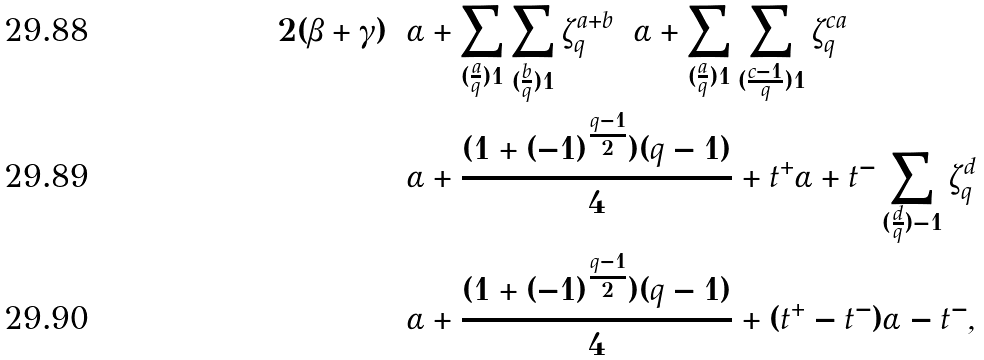<formula> <loc_0><loc_0><loc_500><loc_500>2 ( \beta + \gamma ) & = \alpha + \sum _ { ( \frac { a } { q } ) = 1 } \sum _ { ( \frac { b } { q } ) = 1 } \zeta _ { q } ^ { a + b } = \alpha + \sum _ { ( \frac { a } { q } ) = 1 } \sum _ { ( \frac { c - 1 } q ) = 1 } \zeta _ { q } ^ { c a } \\ & = \alpha + \frac { ( 1 + ( - 1 ) ^ { \frac { q - 1 } 2 } ) ( q - 1 ) } 4 + t ^ { + } \alpha + t ^ { - } \sum _ { ( \frac { d } { q } ) = - 1 } \zeta _ { q } ^ { d } \\ & = \alpha + \frac { ( 1 + ( - 1 ) ^ { \frac { q - 1 } 2 } ) ( q - 1 ) } 4 + ( t ^ { + } - t ^ { - } ) \alpha - t ^ { - } ,</formula> 